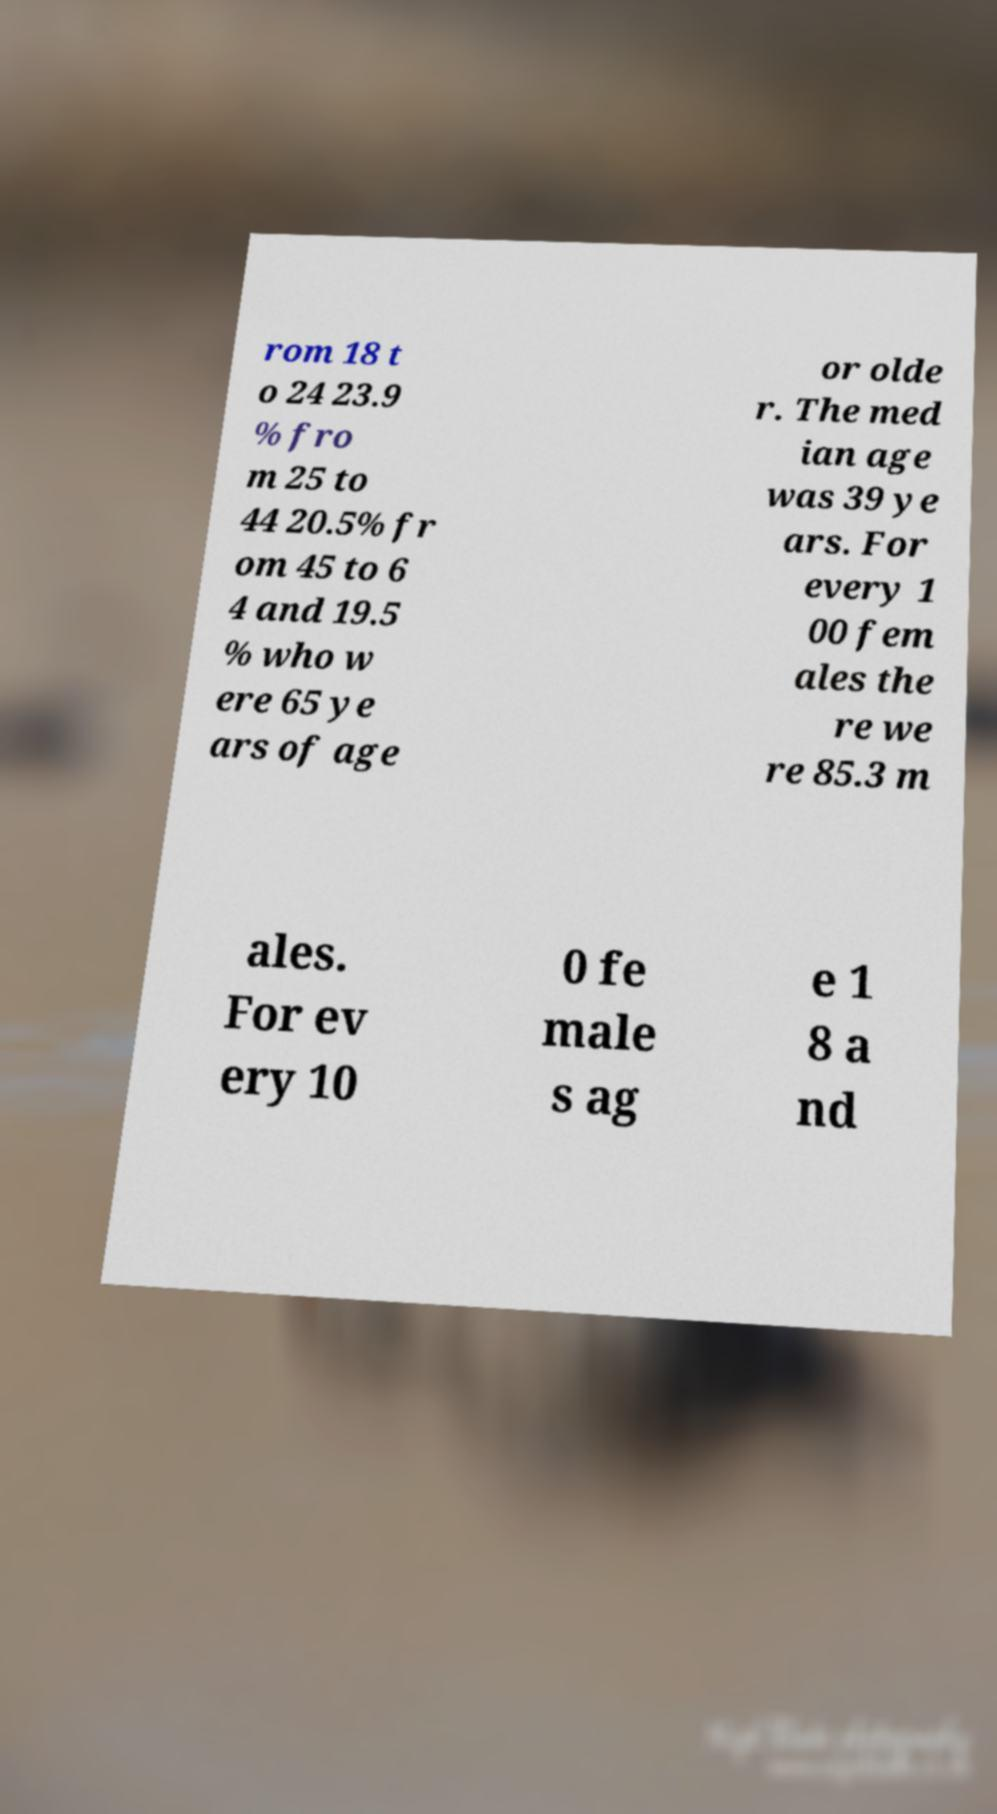For documentation purposes, I need the text within this image transcribed. Could you provide that? rom 18 t o 24 23.9 % fro m 25 to 44 20.5% fr om 45 to 6 4 and 19.5 % who w ere 65 ye ars of age or olde r. The med ian age was 39 ye ars. For every 1 00 fem ales the re we re 85.3 m ales. For ev ery 10 0 fe male s ag e 1 8 a nd 